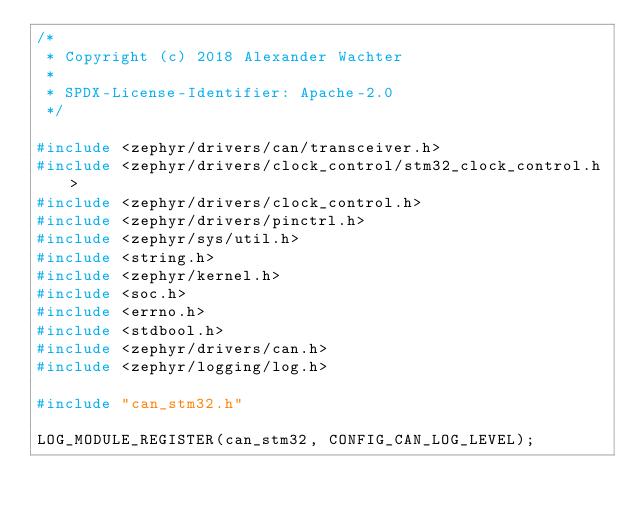<code> <loc_0><loc_0><loc_500><loc_500><_C_>/*
 * Copyright (c) 2018 Alexander Wachter
 *
 * SPDX-License-Identifier: Apache-2.0
 */

#include <zephyr/drivers/can/transceiver.h>
#include <zephyr/drivers/clock_control/stm32_clock_control.h>
#include <zephyr/drivers/clock_control.h>
#include <zephyr/drivers/pinctrl.h>
#include <zephyr/sys/util.h>
#include <string.h>
#include <zephyr/kernel.h>
#include <soc.h>
#include <errno.h>
#include <stdbool.h>
#include <zephyr/drivers/can.h>
#include <zephyr/logging/log.h>

#include "can_stm32.h"

LOG_MODULE_REGISTER(can_stm32, CONFIG_CAN_LOG_LEVEL);
</code> 